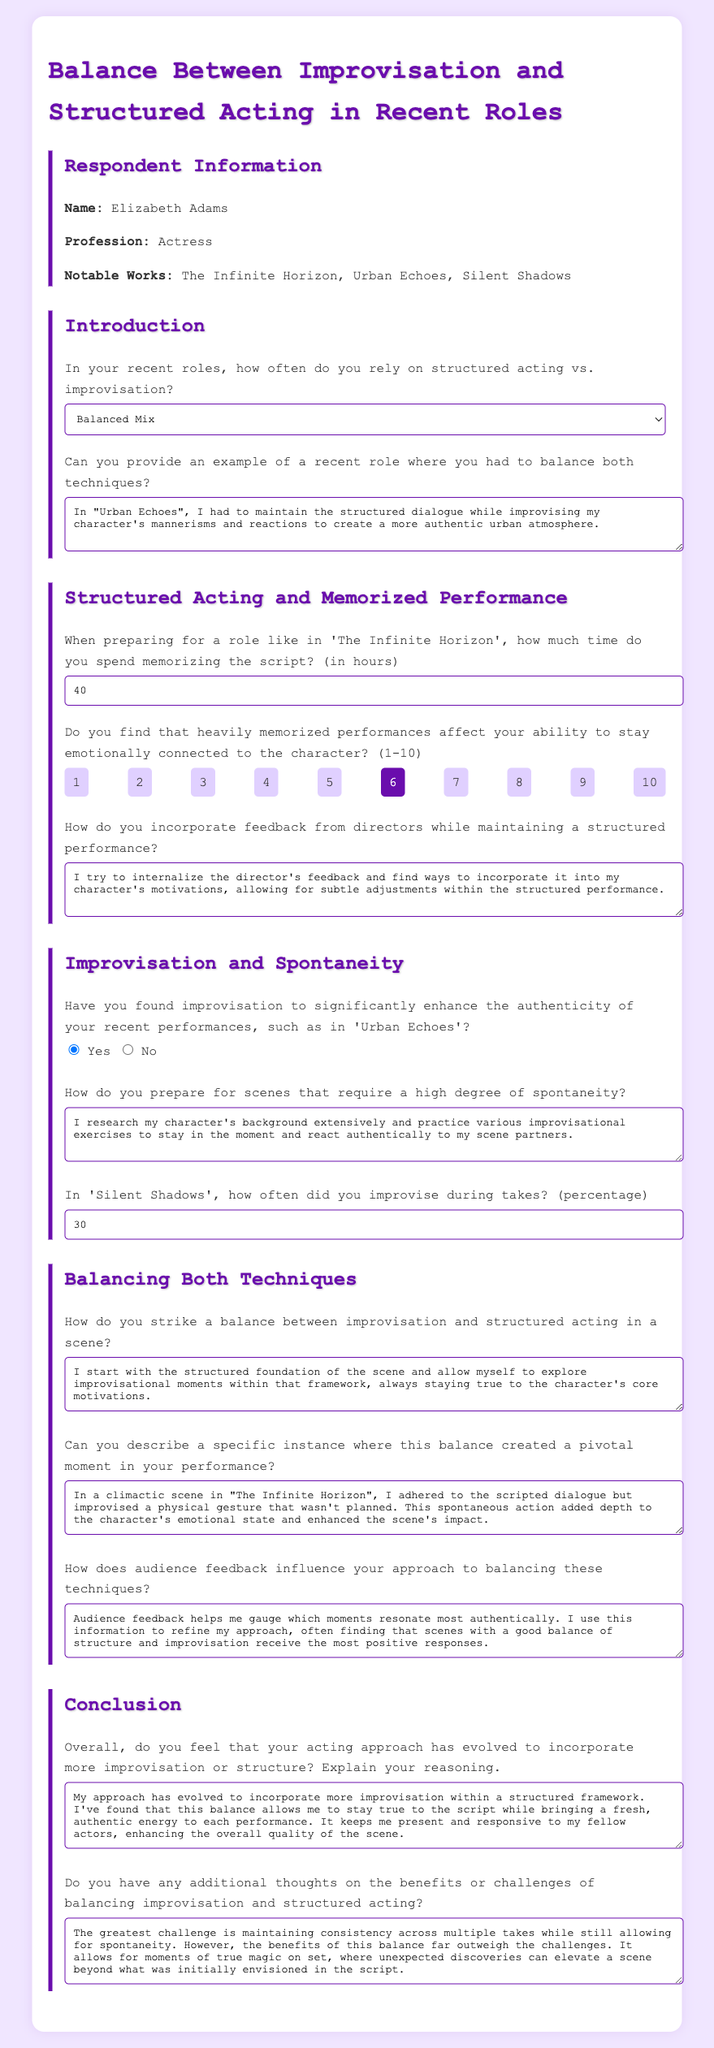What is the name of the respondent? The respondent's name is mentioned in the section titled "Respondent Information".
Answer: Elizabeth Adams In which notable work did the respondent balance structured dialogue and improvisation? The response indicates a specific work where both techniques were balanced.
Answer: Urban Echoes How much time does the respondent spend memorizing scripts for roles? The document provides a direct response regarding the amount of time spent on memorization.
Answer: 40 What rating did the respondent give for emotional connection in memorized performances? The respondent’s rating on emotional connection impacts is expressed using a scale from 1 to 10.
Answer: 6 Did the respondent find improvisation enhances authenticity in performances? The respondent's answer regarding the effect of improvisation on authenticity is captured in a binary choice.
Answer: Yes What percentage of improvisation was used during the takes in 'Silent Shadows'? This reflects the specific numerical answer given about improvisation frequency in a recent role.
Answer: 30 How does the respondent compare the balance of improvisation and structure in their acting approach? The respondent describes their evolving acting technique in the conclusion section.
Answer: More improvisation within a structured framework What challenge does the respondent highlight regarding balancing improvisation and structure? The respondent discusses a challenge they face in maintaining consistency while allowing spontaneity.
Answer: Maintaining consistency across multiple takes What overall trend has the respondent noted regarding their acting approach? The conclusion summarizes the evolution of their approach and its main aspects.
Answer: Evolved to incorporate more improvisation 